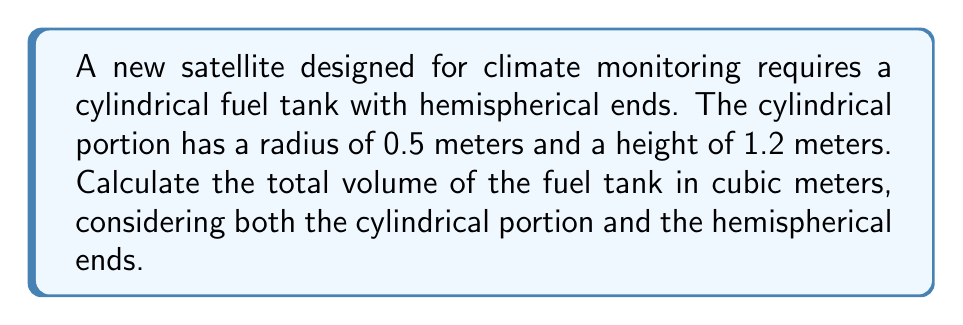Solve this math problem. To calculate the total volume of the fuel tank, we need to sum the volumes of the cylindrical portion and the two hemispherical ends.

1. Volume of the cylindrical portion:
   $$V_{cylinder} = \pi r^2 h$$
   where $r$ is the radius and $h$ is the height of the cylinder.
   $$V_{cylinder} = \pi (0.5\text{ m})^2 (1.2\text{ m}) = 0.3\pi\text{ m}^3$$

2. Volume of one hemisphere:
   $$V_{hemisphere} = \frac{2}{3}\pi r^3$$
   $$V_{hemisphere} = \frac{2}{3}\pi (0.5\text{ m})^3 = \frac{1}{24}\pi\text{ m}^3$$

3. Total volume of both hemispheres:
   $$V_{hemispheres} = 2 \cdot \frac{1}{24}\pi\text{ m}^3 = \frac{1}{12}\pi\text{ m}^3$$

4. Total volume of the fuel tank:
   $$V_{total} = V_{cylinder} + V_{hemispheres}$$
   $$V_{total} = 0.3\pi\text{ m}^3 + \frac{1}{12}\pi\text{ m}^3 = \frac{11}{12}\pi\text{ m}^3$$

5. Calculating the final value:
   $$V_{total} = \frac{11}{12}\pi\text{ m}^3 \approx 2.8797\text{ m}^3$$
Answer: $\frac{11}{12}\pi\text{ m}^3$ or approximately $2.8797\text{ m}^3$ 